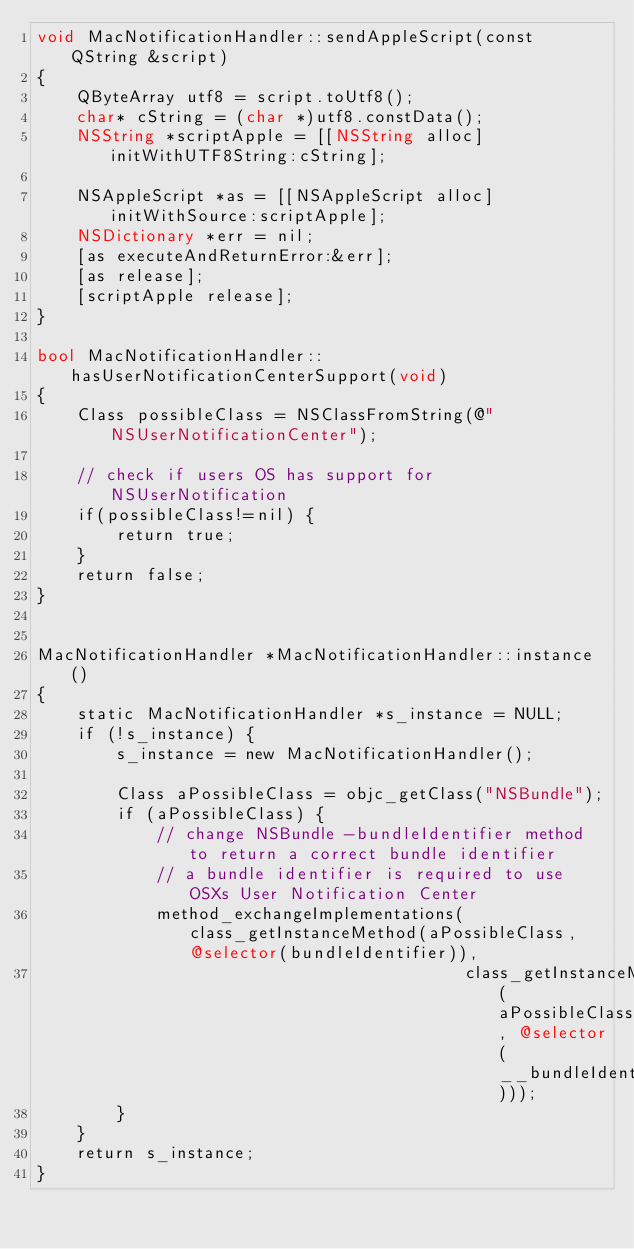Convert code to text. <code><loc_0><loc_0><loc_500><loc_500><_ObjectiveC_>void MacNotificationHandler::sendAppleScript(const QString &script)
{
    QByteArray utf8 = script.toUtf8();
    char* cString = (char *)utf8.constData();
    NSString *scriptApple = [[NSString alloc] initWithUTF8String:cString];

    NSAppleScript *as = [[NSAppleScript alloc] initWithSource:scriptApple];
    NSDictionary *err = nil;
    [as executeAndReturnError:&err];
    [as release];
    [scriptApple release];
}

bool MacNotificationHandler::hasUserNotificationCenterSupport(void)
{
    Class possibleClass = NSClassFromString(@"NSUserNotificationCenter");

    // check if users OS has support for NSUserNotification
    if(possibleClass!=nil) {
        return true;
    }
    return false;
}


MacNotificationHandler *MacNotificationHandler::instance()
{
    static MacNotificationHandler *s_instance = NULL;
    if (!s_instance) {
        s_instance = new MacNotificationHandler();
        
        Class aPossibleClass = objc_getClass("NSBundle");
        if (aPossibleClass) {
            // change NSBundle -bundleIdentifier method to return a correct bundle identifier
            // a bundle identifier is required to use OSXs User Notification Center
            method_exchangeImplementations(class_getInstanceMethod(aPossibleClass, @selector(bundleIdentifier)),
                                           class_getInstanceMethod(aPossibleClass, @selector(__bundleIdentifier)));
        }
    }
    return s_instance;
}
</code> 